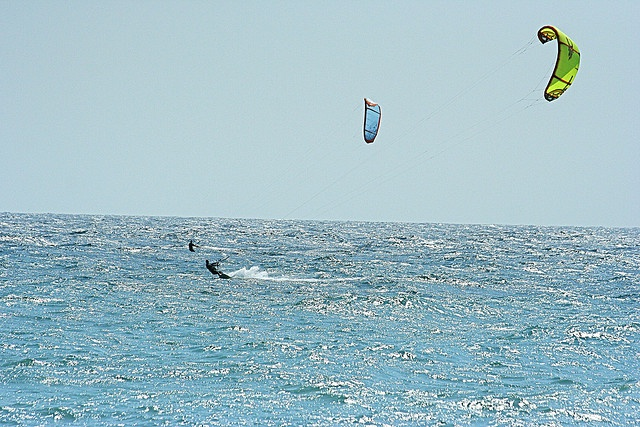Describe the objects in this image and their specific colors. I can see kite in lightblue, green, black, darkgreen, and yellow tones, kite in lightblue, black, and gray tones, people in lightblue, black, gray, lightgray, and darkgray tones, surfboard in lightblue, lightgray, darkgray, and black tones, and people in lightblue, black, gray, and darkblue tones in this image. 